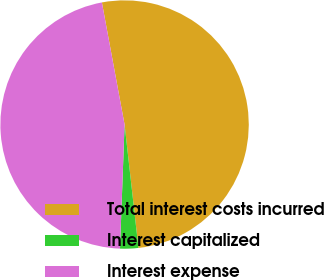<chart> <loc_0><loc_0><loc_500><loc_500><pie_chart><fcel>Total interest costs incurred<fcel>Interest capitalized<fcel>Interest expense<nl><fcel>51.14%<fcel>2.37%<fcel>46.49%<nl></chart> 